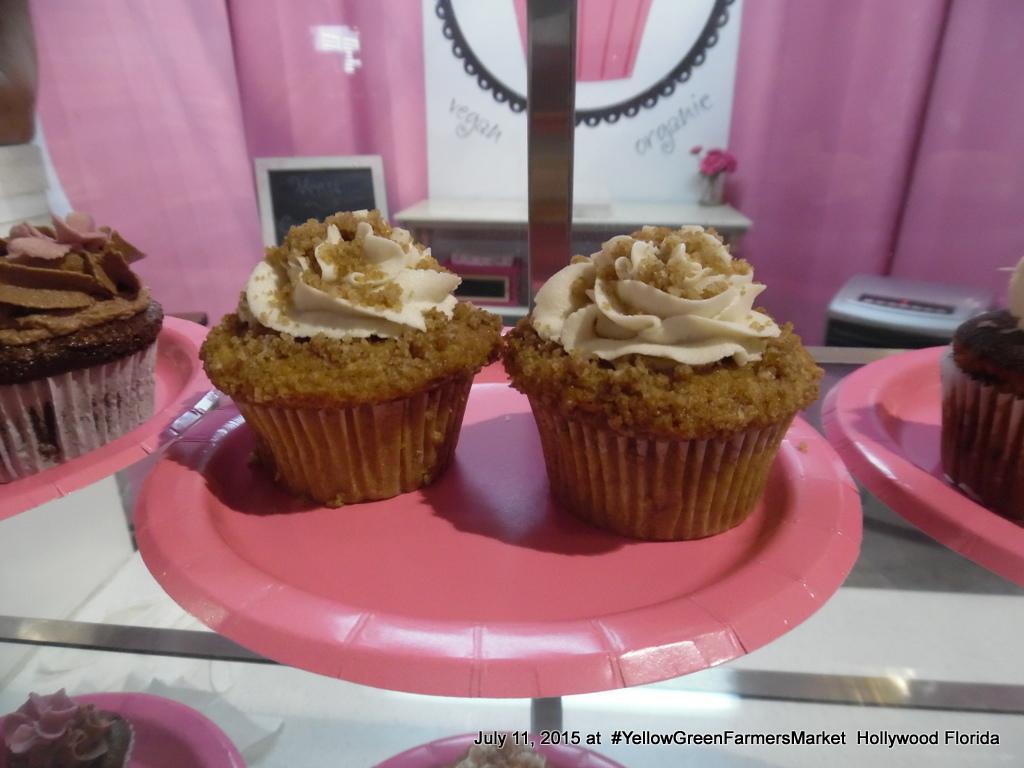Please provide a concise description of this image. We can see cupcakes in the plates on a glass platform. Through the glass we can see likes on a platform. In the background there is a hoarding and flower vase on a table, curtain, photo frame and other objects. 